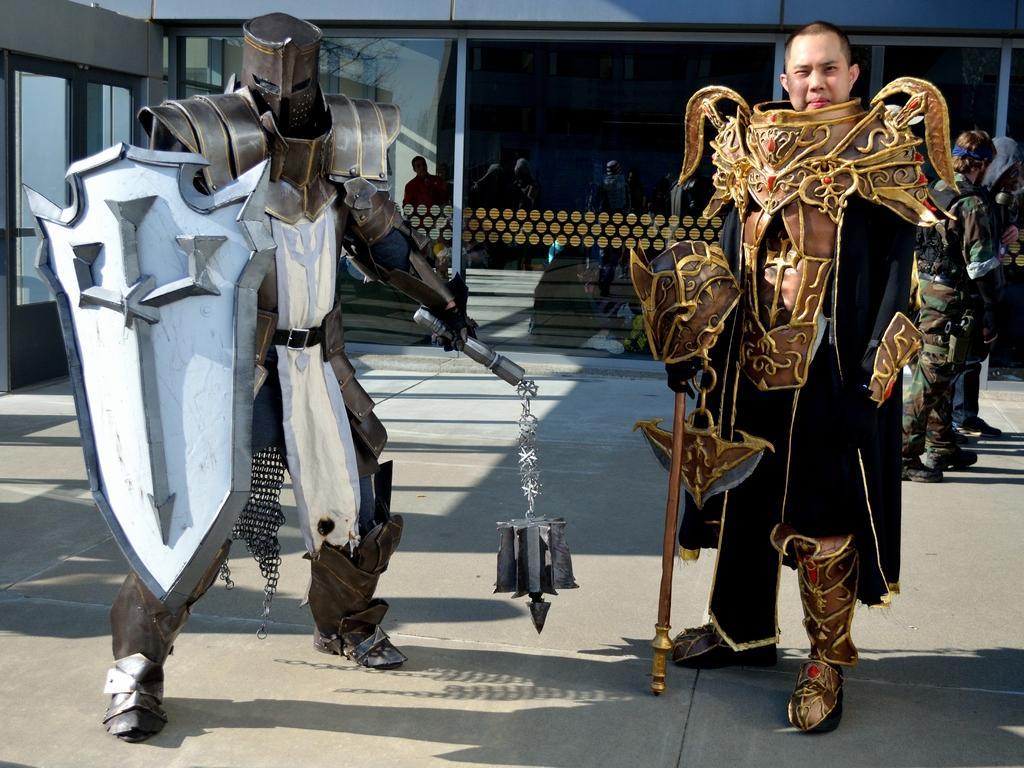Can you describe this image briefly? In this image there are two persons standing on the floor by wearing the costumes of the super heroes. In the background there is glass. On the right side there are few people standing on the floor. 